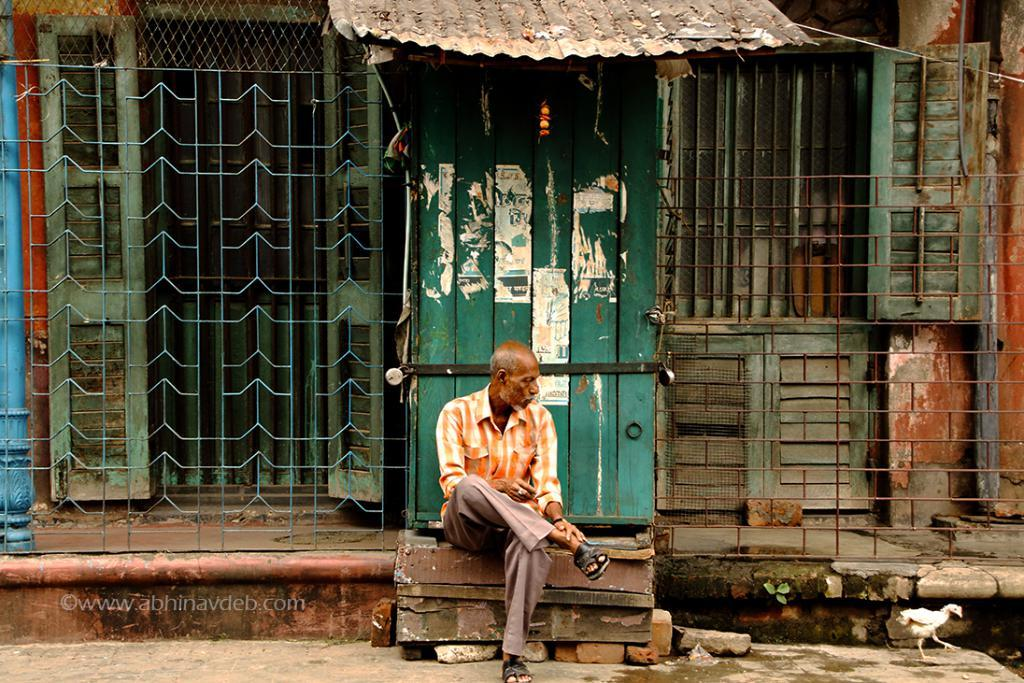What type of structure is visible in the image? There is a house in the image. What is the main feature of the house's exterior? The house has a roof. How can one enter the house? The house has doors. Who is present near the house? There is a person in front of the door. What animal can be seen on the right side of the image? There is a hen on the right side of the image. What type of pancake is being pulled by the person in the image? There is no pancake present in the image, and the person is not pulling anything. Where is the basket located in the image? There is no basket present in the image. 